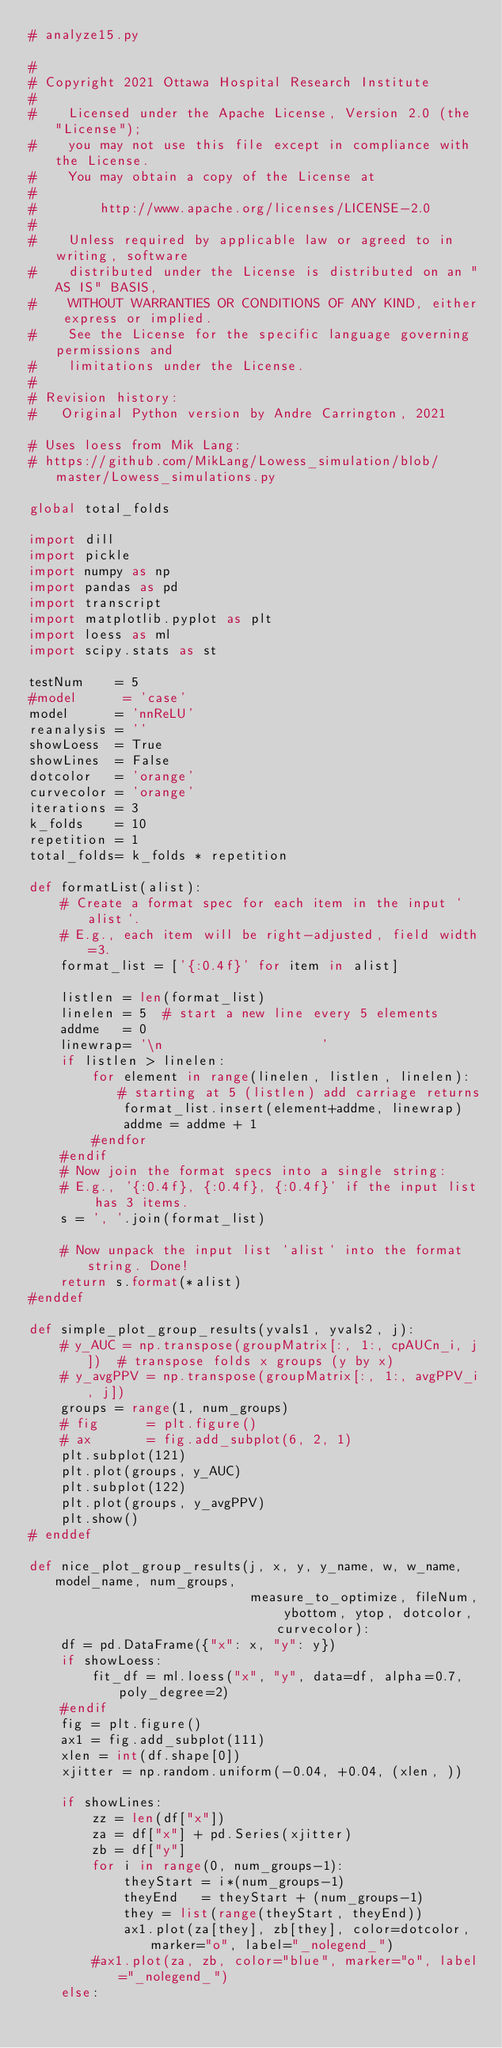<code> <loc_0><loc_0><loc_500><loc_500><_Python_># analyze15.py

#
# Copyright 2021 Ottawa Hospital Research Institute
#
#    Licensed under the Apache License, Version 2.0 (the "License");
#    you may not use this file except in compliance with the License.
#    You may obtain a copy of the License at
#
#        http://www.apache.org/licenses/LICENSE-2.0
#
#    Unless required by applicable law or agreed to in writing, software
#    distributed under the License is distributed on an "AS IS" BASIS,
#    WITHOUT WARRANTIES OR CONDITIONS OF ANY KIND, either express or implied.
#    See the License for the specific language governing permissions and
#    limitations under the License.
#
# Revision history:
#   Original Python version by Andre Carrington, 2021

# Uses loess from Mik Lang:
# https://github.com/MikLang/Lowess_simulation/blob/master/Lowess_simulations.py

global total_folds

import dill
import pickle
import numpy as np
import pandas as pd
import transcript
import matplotlib.pyplot as plt
import loess as ml
import scipy.stats as st

testNum    = 5
#model      = 'case'
model      = 'nnReLU'
reanalysis = ''
showLoess  = True
showLines  = False
dotcolor   = 'orange'
curvecolor = 'orange'
iterations = 3
k_folds    = 10
repetition = 1
total_folds= k_folds * repetition

def formatList(alist):
    # Create a format spec for each item in the input `alist`.
    # E.g., each item will be right-adjusted, field width=3.
    format_list = ['{:0.4f}' for item in alist]

    listlen = len(format_list)
    linelen = 5  # start a new line every 5 elements
    addme   = 0
    linewrap= '\n                    ' 
    if listlen > linelen:
        for element in range(linelen, listlen, linelen): # starting at 5 (listlen) add carriage returns
            format_list.insert(element+addme, linewrap)
            addme = addme + 1
        #endfor
    #endif
    # Now join the format specs into a single string:
    # E.g., '{:0.4f}, {:0.4f}, {:0.4f}' if the input list has 3 items.
    s = ', '.join(format_list)

    # Now unpack the input list `alist` into the format string. Done!
    return s.format(*alist)
#enddef

def simple_plot_group_results(yvals1, yvals2, j):
    # y_AUC = np.transpose(groupMatrix[:, 1:, cpAUCn_i, j])  # transpose folds x groups (y by x)
    # y_avgPPV = np.transpose(groupMatrix[:, 1:, avgPPV_i, j])
    groups = range(1, num_groups)
    # fig      = plt.figure()
    # ax       = fig.add_subplot(6, 2, 1)
    plt.subplot(121)
    plt.plot(groups, y_AUC)
    plt.subplot(122)
    plt.plot(groups, y_avgPPV)
    plt.show()
# enddef

def nice_plot_group_results(j, x, y, y_name, w, w_name, model_name, num_groups,
                            measure_to_optimize, fileNum, ybottom, ytop, dotcolor, curvecolor):
    df = pd.DataFrame({"x": x, "y": y})
    if showLoess:
        fit_df = ml.loess("x", "y", data=df, alpha=0.7, poly_degree=2)
    #endif
    fig = plt.figure()
    ax1 = fig.add_subplot(111)
    xlen = int(df.shape[0])
    xjitter = np.random.uniform(-0.04, +0.04, (xlen, ))

    if showLines:
        zz = len(df["x"])
        za = df["x"] + pd.Series(xjitter)
        zb = df["y"]
        for i in range(0, num_groups-1):
            theyStart = i*(num_groups-1)
            theyEnd   = theyStart + (num_groups-1)
            they = list(range(theyStart, theyEnd))
            ax1.plot(za[they], zb[they], color=dotcolor, marker="o", label="_nolegend_")
        #ax1.plot(za, zb, color="blue", marker="o", label="_nolegend_")
    else:</code> 